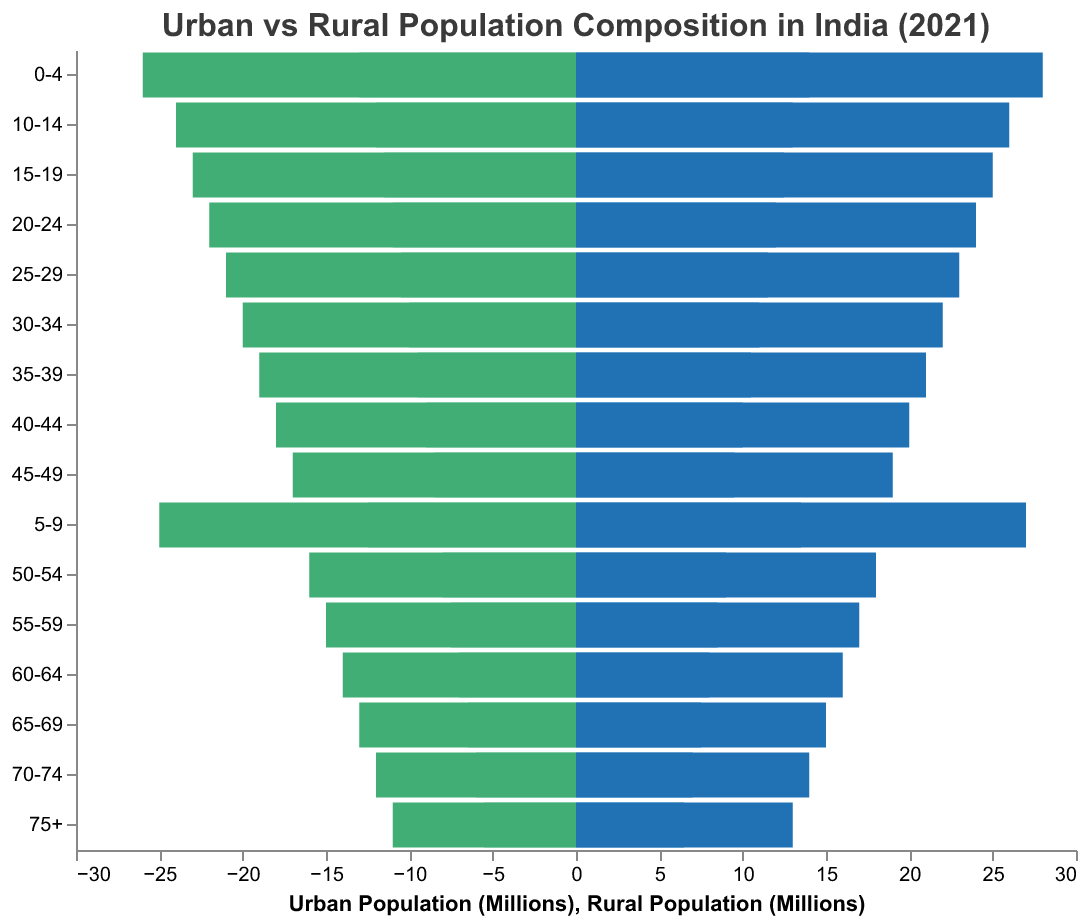What age group do the bars represent at the top of the chart? The age groups are listed vertically on the y-axis starting with the youngest at the top, which is the "0-4" age group.
Answer: 0-4 Which group has the highest population in the "0-4" age group, Urban Males or Rural Males? Look at the two bars corresponding to Urban Males and Rural Males for the "0-4" age group. Compare the length of the bars; the longer bar represents the higher population. The Rural Male bar is longer.
Answer: Rural Males What is the total population of Urban Males and Females in the "20-24" age group? Add the populations of Urban Males and Urban Females in the "20-24" age group: 12 million + 11 million = 23 million.
Answer: 23 million Which population is larger: Rural Females aged 75+ or Urban Males aged 55-59? Compare the lengths of the bars for Rural Females aged 75+ (11 million) and Urban Males aged 55-59 (8.5 million). Rural Females have a larger population.
Answer: Rural Females aged 75+ How does the urban female population in the "35-39" age group compare to the urban male population in the same age group? Compare the lengths of the bars for Urban Females (9.5 million) versus Urban Males (10.5 million) in the "35-39" age group. Urban Males outnumber Urban Females.
Answer: Urban Males outnumber Urban Females What age group has the smallest urban population (males and females combined)? To find the smallest urban population, sum the male and female populations for each age group. The smallest combined urban population is found in the "75+" age group (6.5 million males + 5.5 million females = 12 million).
Answer: 75+ In the "50-54" age group, what is the difference between the rural male population and the rural female population? Subtract the rural female population from the rural male population in the "50-54" age group: 18 million - 16 million = 2 million.
Answer: 2 million How does the population pyramid indicate the trend of urban versus rural population composition in India? Look at the overall shape of the bars: rural populations (both male and female) generally have larger values across most age groups compared to their urban counterparts, indicating a larger rural population.
Answer: Larger rural population Which age group shows the most balanced population between urban males and females? Look for the age group where the bars for urban males and females are closest in length. The "5-9" age group has Urban Males at 13.5 million and Urban Females at 12.5 million.
Answer: 5-9 